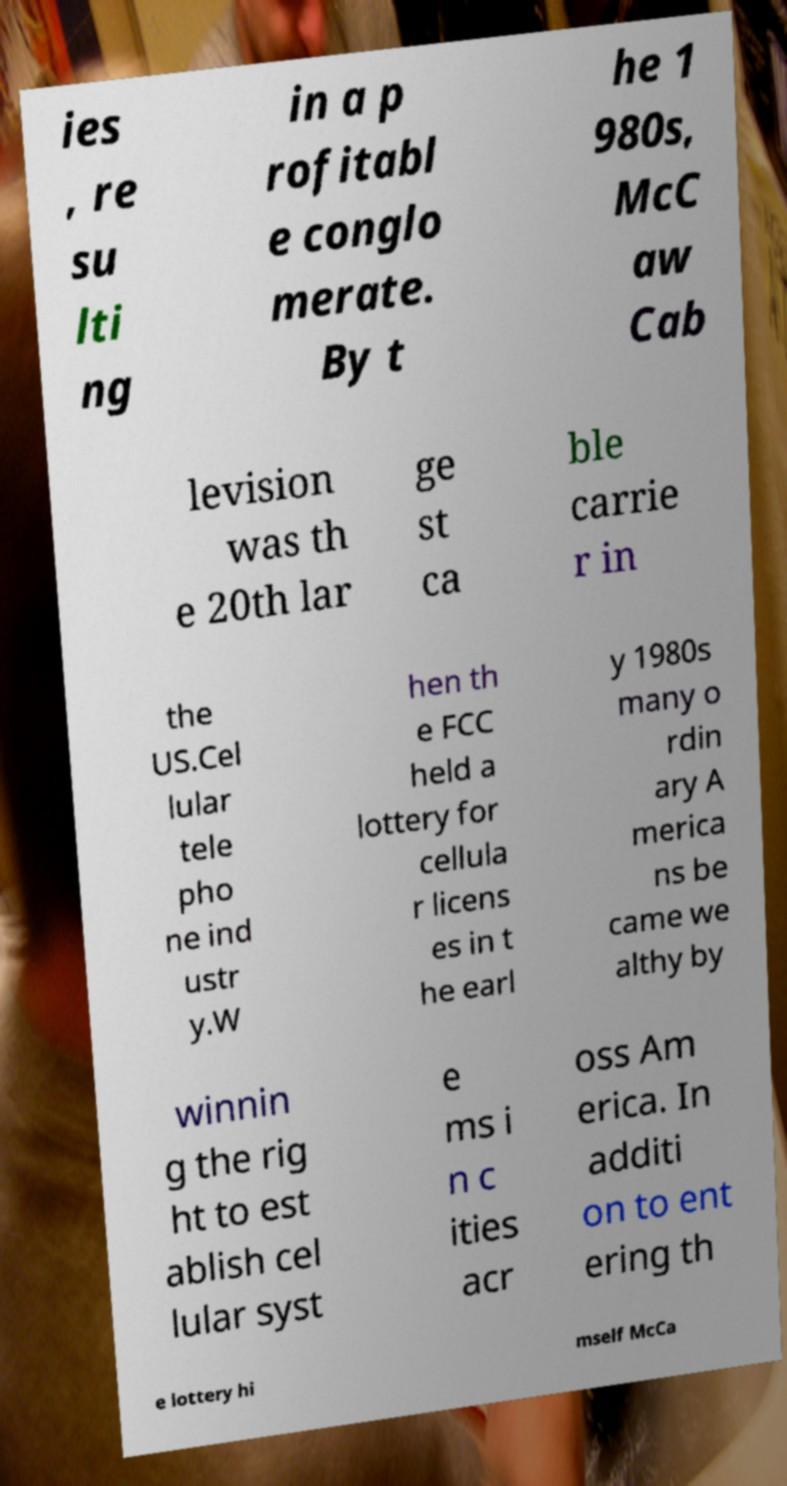Can you accurately transcribe the text from the provided image for me? ies , re su lti ng in a p rofitabl e conglo merate. By t he 1 980s, McC aw Cab levision was th e 20th lar ge st ca ble carrie r in the US.Cel lular tele pho ne ind ustr y.W hen th e FCC held a lottery for cellula r licens es in t he earl y 1980s many o rdin ary A merica ns be came we althy by winnin g the rig ht to est ablish cel lular syst e ms i n c ities acr oss Am erica. In additi on to ent ering th e lottery hi mself McCa 